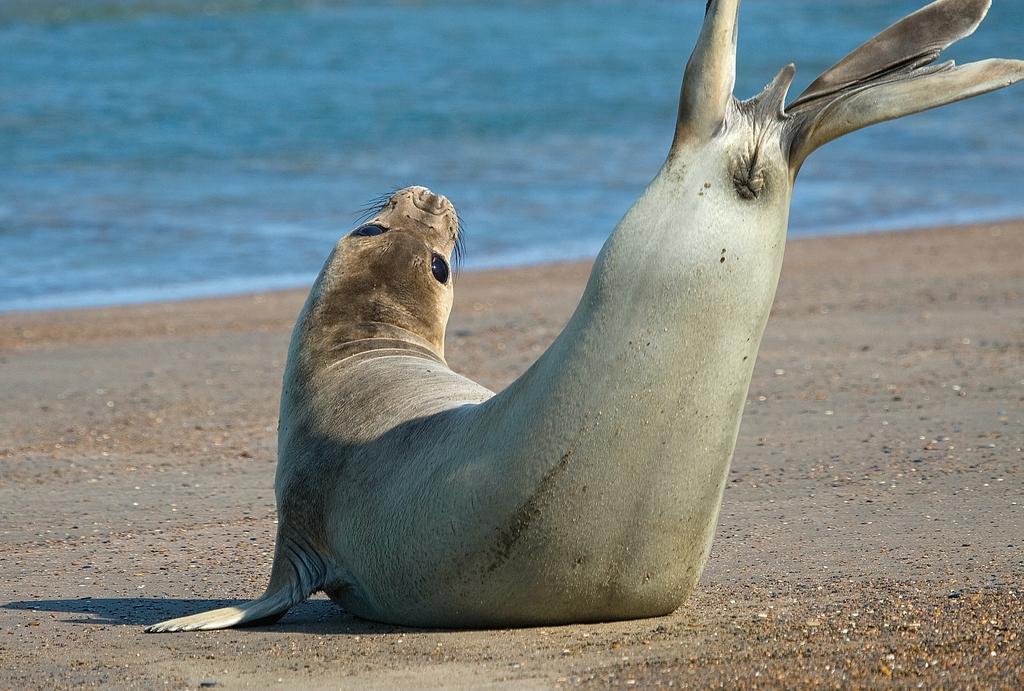Can you describe this image briefly? Here we can see a seal on the sand. In the background we can see water. 